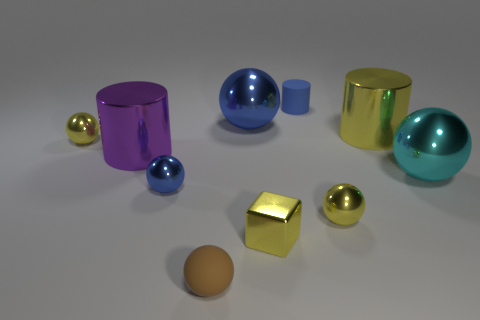There is a tiny metal ball that is right of the brown matte ball; is it the same color as the large shiny cylinder to the right of the tiny matte cylinder?
Offer a terse response. Yes. There is a rubber thing that is in front of the tiny blue thing in front of the large cyan metal sphere; what is its shape?
Your answer should be compact. Sphere. Is there a yellow object of the same size as the purple shiny object?
Give a very brief answer. Yes. What number of blue metallic objects have the same shape as the cyan object?
Keep it short and to the point. 2. Are there an equal number of rubber objects that are in front of the cyan shiny ball and yellow things in front of the tiny metallic block?
Provide a succinct answer. No. Are any tiny red rubber cylinders visible?
Provide a short and direct response. No. What is the size of the matte thing that is left of the blue rubber cylinder that is behind the small yellow sphere that is in front of the tiny blue sphere?
Your answer should be very brief. Small. There is a purple metal thing that is the same size as the cyan metal thing; what shape is it?
Your answer should be compact. Cylinder. How many things are matte things in front of the cyan ball or purple shiny cubes?
Provide a succinct answer. 1. Is there a yellow sphere that is behind the blue thing that is in front of the large cyan metallic ball that is in front of the big yellow metallic cylinder?
Give a very brief answer. Yes. 